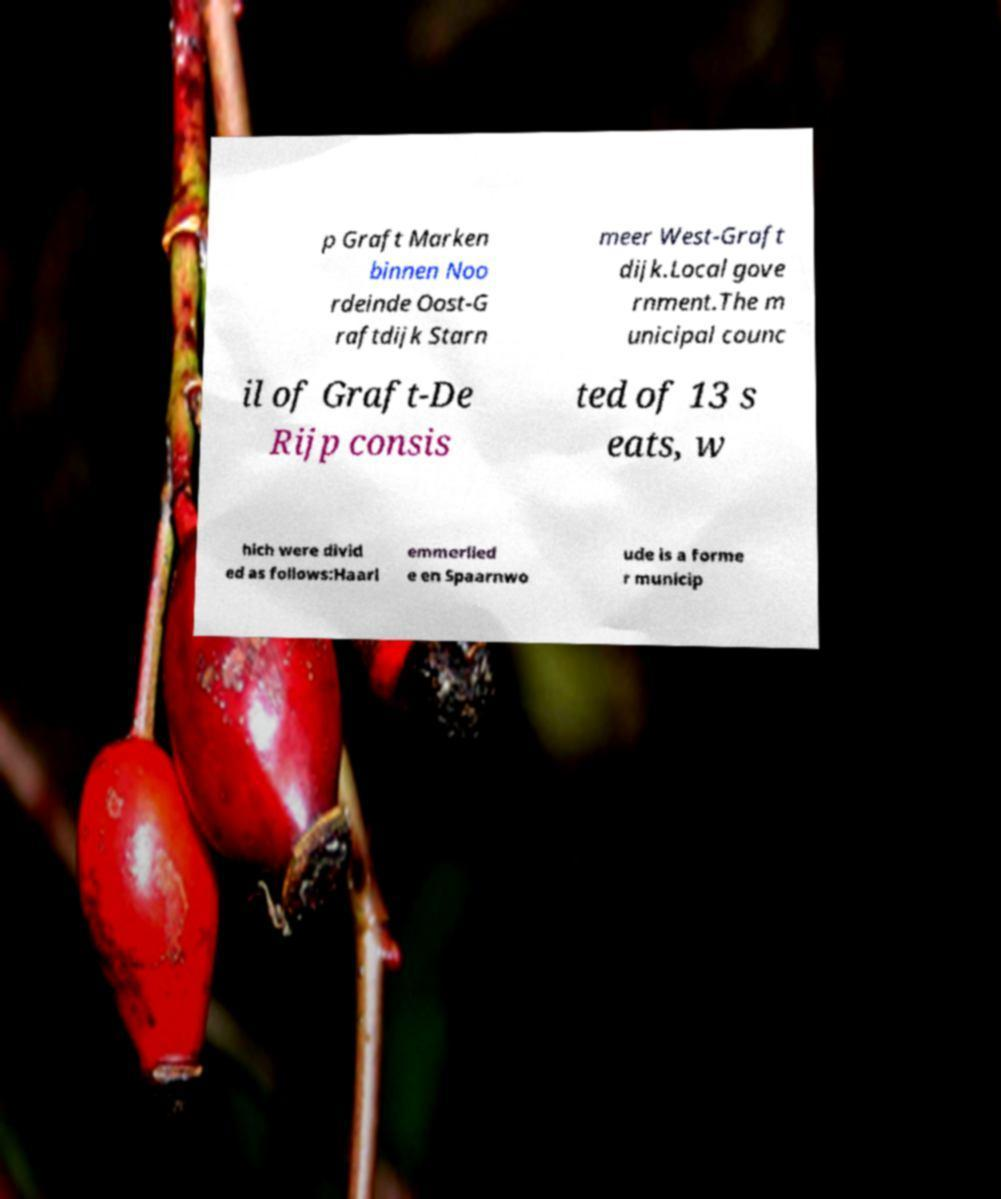Could you extract and type out the text from this image? p Graft Marken binnen Noo rdeinde Oost-G raftdijk Starn meer West-Graft dijk.Local gove rnment.The m unicipal counc il of Graft-De Rijp consis ted of 13 s eats, w hich were divid ed as follows:Haarl emmerlied e en Spaarnwo ude is a forme r municip 